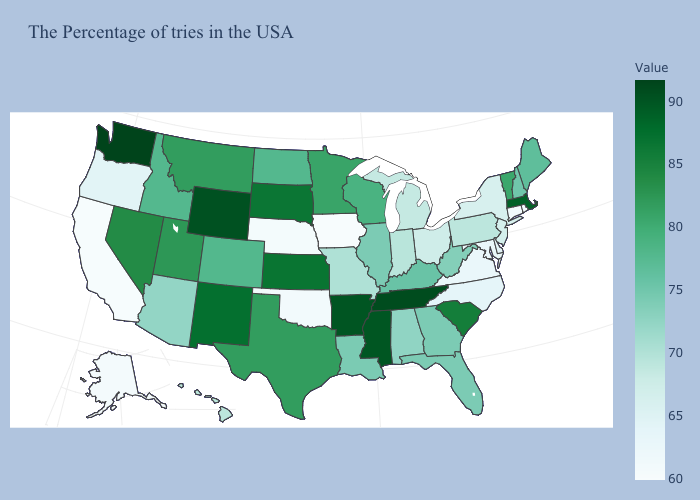Does Idaho have a higher value than Michigan?
Quick response, please. Yes. Which states have the highest value in the USA?
Write a very short answer. Washington. Does Hawaii have the lowest value in the USA?
Keep it brief. No. Which states hav the highest value in the MidWest?
Give a very brief answer. Kansas. Among the states that border Florida , does Alabama have the lowest value?
Quick response, please. Yes. Does Alabama have a higher value than California?
Be succinct. Yes. Does Michigan have a higher value than Texas?
Answer briefly. No. Does Iowa have the lowest value in the USA?
Answer briefly. Yes. Is the legend a continuous bar?
Short answer required. Yes. Among the states that border Illinois , which have the highest value?
Answer briefly. Wisconsin. Is the legend a continuous bar?
Be succinct. Yes. 